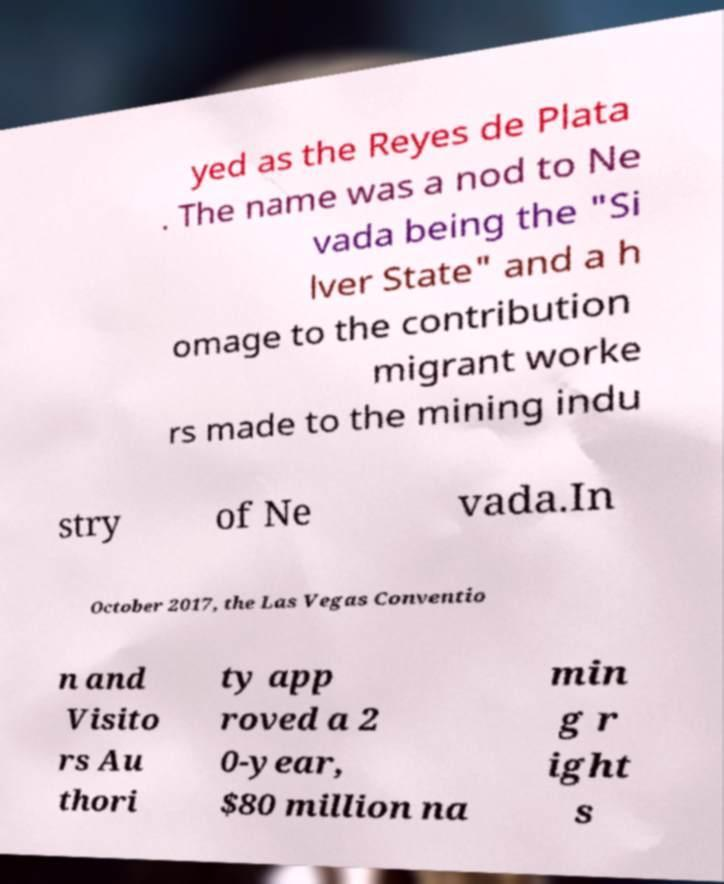Could you assist in decoding the text presented in this image and type it out clearly? yed as the Reyes de Plata . The name was a nod to Ne vada being the "Si lver State" and a h omage to the contribution migrant worke rs made to the mining indu stry of Ne vada.In October 2017, the Las Vegas Conventio n and Visito rs Au thori ty app roved a 2 0-year, $80 million na min g r ight s 